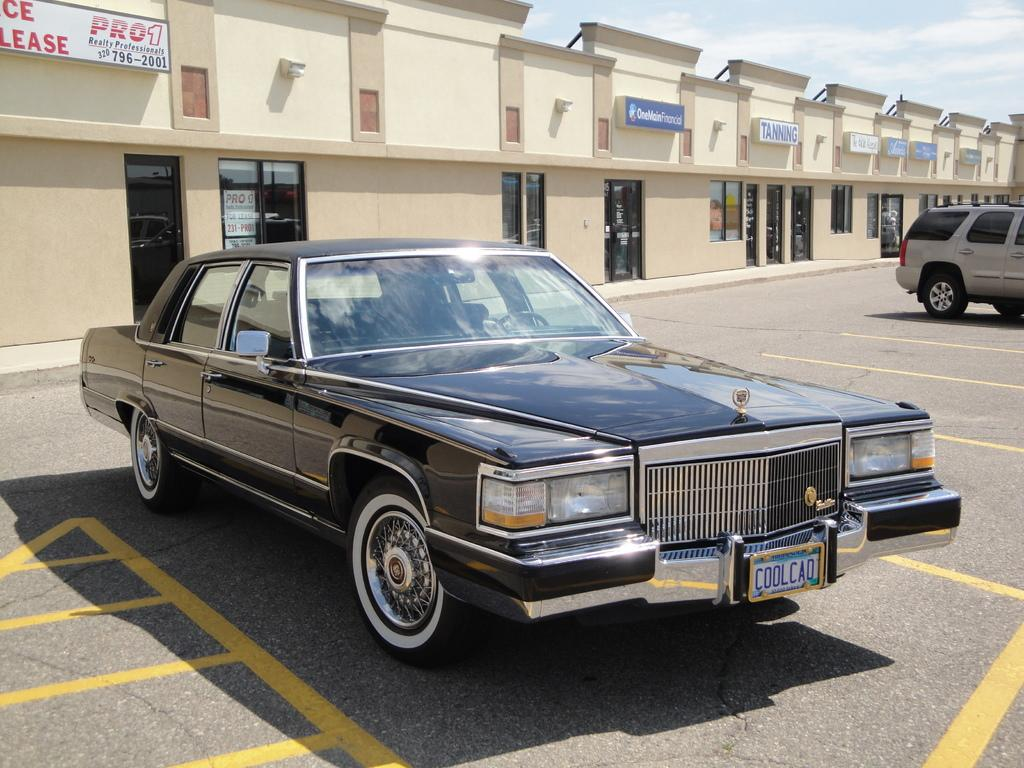What is happening on the road in the image? Vehicles are on the road in the image. What type of establishments can be seen in the image? There are stores visible in the image. What is present above the stores? There are hoardings above the stores. What type of material is used for the windows and doors in the image? Glass windows and doors are visible in the image. What color is the shirt hanging on the canvas in the image? There is no shirt or canvas present in the image. How many steps are visible in the image? There are no steps visible in the image. 